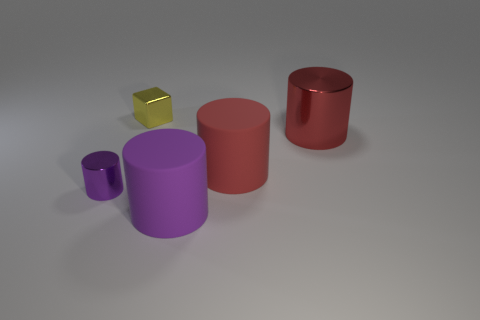There is a cube; is it the same size as the metal cylinder to the right of the yellow shiny object?
Your answer should be very brief. No. What number of yellow cubes have the same size as the purple matte thing?
Your answer should be very brief. 0. There is a small block that is the same material as the small cylinder; what is its color?
Offer a terse response. Yellow. Are there more green metal cylinders than large red shiny objects?
Your answer should be compact. No. Is the material of the small cube the same as the large purple cylinder?
Provide a succinct answer. No. There is a large red object that is made of the same material as the large purple thing; what shape is it?
Keep it short and to the point. Cylinder. Is the number of tiny red metal cylinders less than the number of big red matte cylinders?
Ensure brevity in your answer.  Yes. There is a large cylinder that is on the left side of the big red shiny cylinder and right of the big purple matte cylinder; what is it made of?
Ensure brevity in your answer.  Rubber. How big is the rubber object that is behind the metal cylinder that is in front of the metallic object on the right side of the tiny yellow metal thing?
Provide a short and direct response. Large. There is a big shiny object; does it have the same shape as the small thing in front of the red shiny object?
Keep it short and to the point. Yes. 